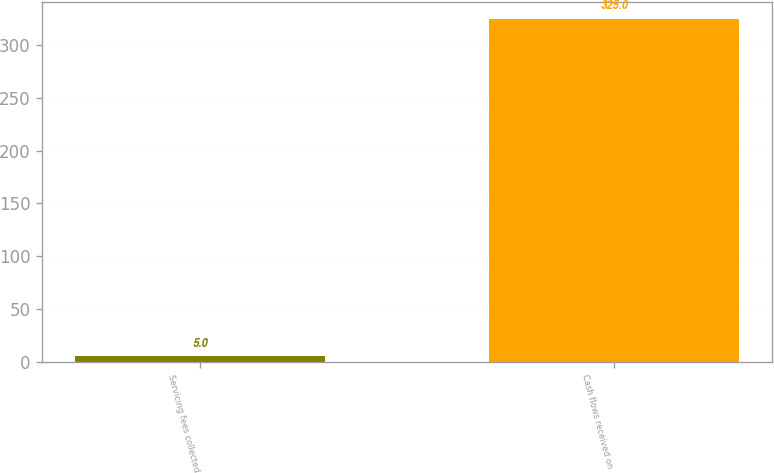Convert chart. <chart><loc_0><loc_0><loc_500><loc_500><bar_chart><fcel>Servicing fees collected<fcel>Cash flows received on<nl><fcel>5<fcel>325<nl></chart> 